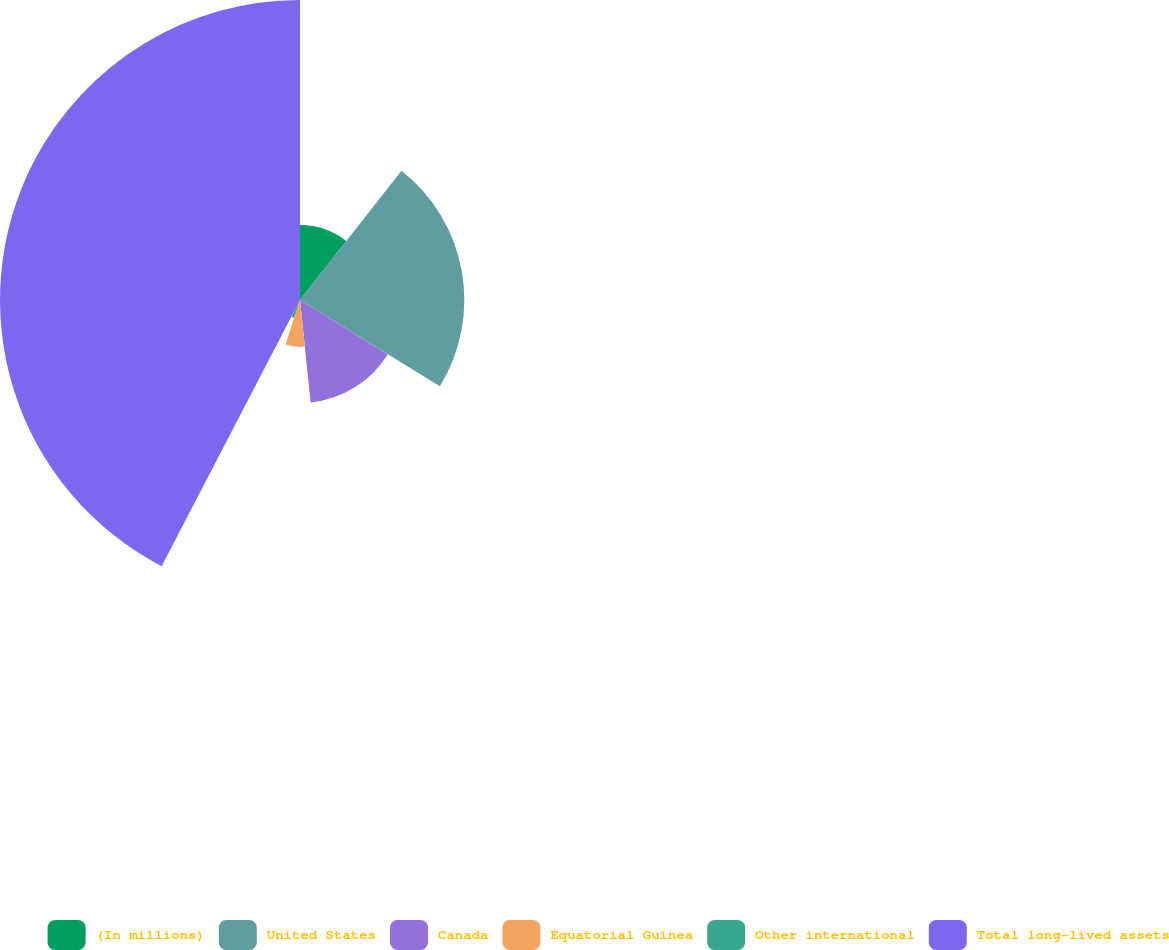Convert chart to OTSL. <chart><loc_0><loc_0><loc_500><loc_500><pie_chart><fcel>(In millions)<fcel>United States<fcel>Canada<fcel>Equatorial Guinea<fcel>Other international<fcel>Total long-lived assets<nl><fcel>10.59%<fcel>23.21%<fcel>14.56%<fcel>6.62%<fcel>2.65%<fcel>42.37%<nl></chart> 